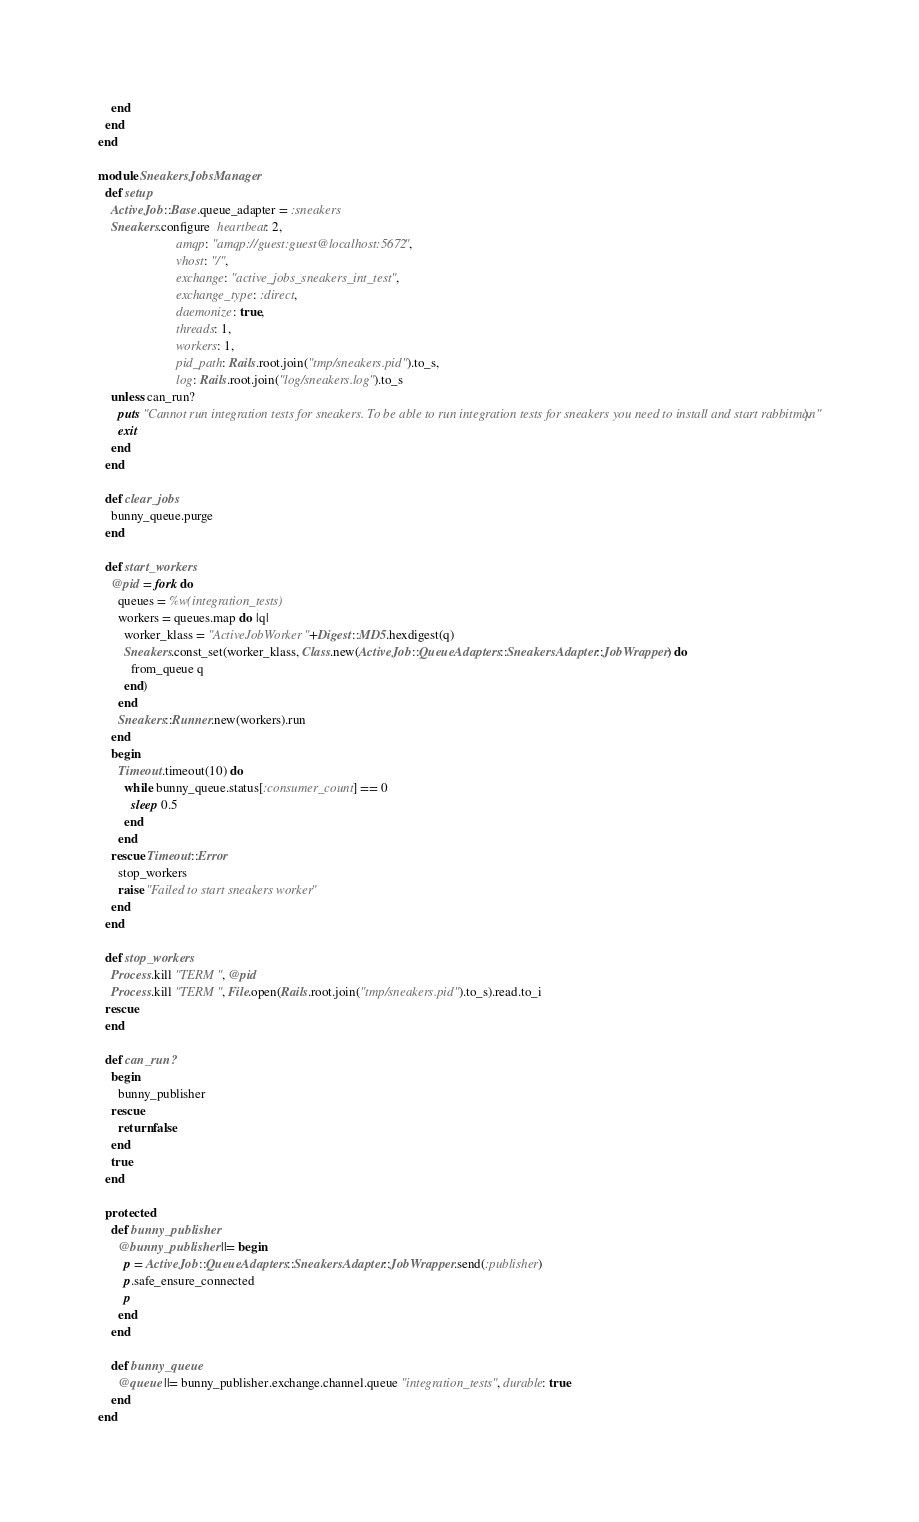Convert code to text. <code><loc_0><loc_0><loc_500><loc_500><_Ruby_>    end
  end
end

module SneakersJobsManager
  def setup
    ActiveJob::Base.queue_adapter = :sneakers
    Sneakers.configure  heartbeat: 2,
                        amqp: "amqp://guest:guest@localhost:5672",
                        vhost: "/",
                        exchange: "active_jobs_sneakers_int_test",
                        exchange_type: :direct,
                        daemonize: true,
                        threads: 1,
                        workers: 1,
                        pid_path: Rails.root.join("tmp/sneakers.pid").to_s,
                        log: Rails.root.join("log/sneakers.log").to_s
    unless can_run?
      puts "Cannot run integration tests for sneakers. To be able to run integration tests for sneakers you need to install and start rabbitmq.\n"
      exit
    end
  end

  def clear_jobs
    bunny_queue.purge
  end

  def start_workers
    @pid = fork do
      queues = %w(integration_tests)
      workers = queues.map do |q|
        worker_klass = "ActiveJobWorker"+Digest::MD5.hexdigest(q)
        Sneakers.const_set(worker_klass, Class.new(ActiveJob::QueueAdapters::SneakersAdapter::JobWrapper) do
          from_queue q
        end)
      end
      Sneakers::Runner.new(workers).run
    end
    begin
      Timeout.timeout(10) do
        while bunny_queue.status[:consumer_count] == 0
          sleep 0.5
        end
      end
    rescue Timeout::Error
      stop_workers
      raise "Failed to start sneakers worker"
    end
  end

  def stop_workers
    Process.kill "TERM", @pid
    Process.kill "TERM", File.open(Rails.root.join("tmp/sneakers.pid").to_s).read.to_i
  rescue
  end

  def can_run?
    begin
      bunny_publisher
    rescue
      return false
    end
    true
  end

  protected
    def bunny_publisher
      @bunny_publisher ||= begin
        p = ActiveJob::QueueAdapters::SneakersAdapter::JobWrapper.send(:publisher)
        p.safe_ensure_connected
        p
      end
    end

    def bunny_queue
      @queue ||= bunny_publisher.exchange.channel.queue "integration_tests", durable: true
    end
end
</code> 